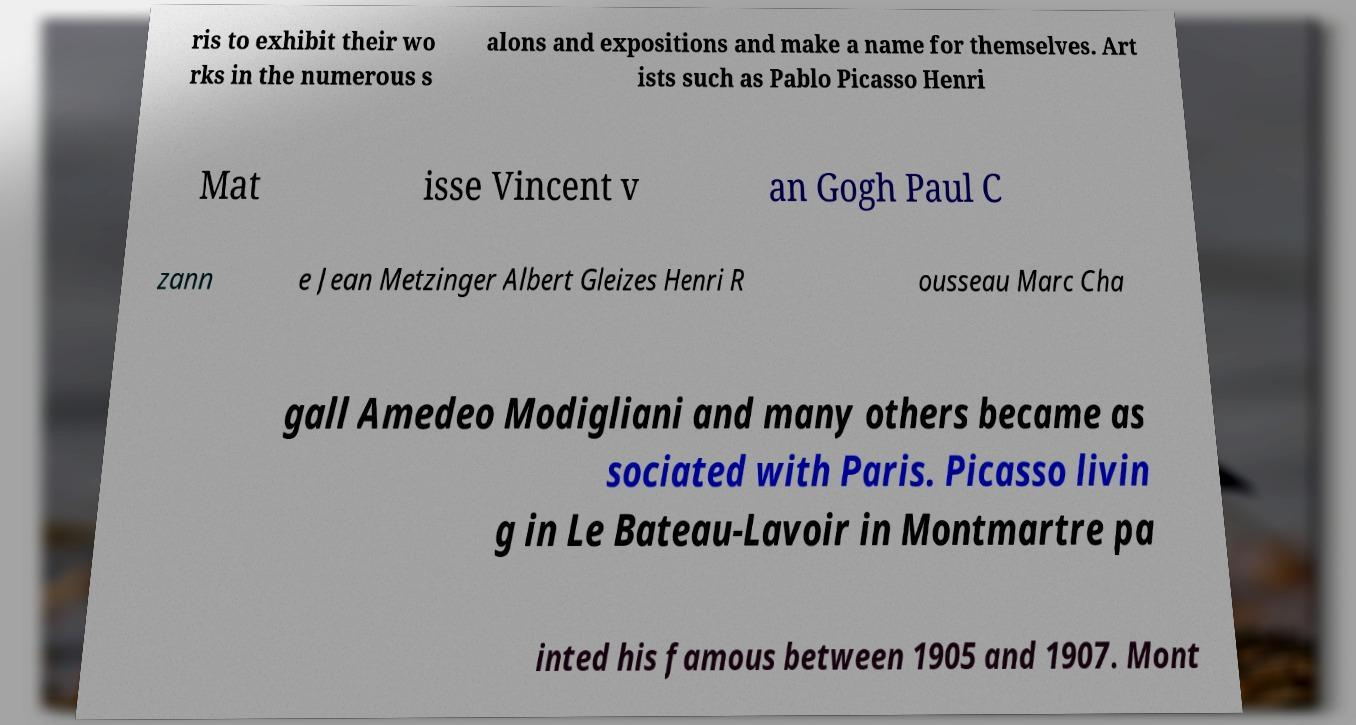I need the written content from this picture converted into text. Can you do that? ris to exhibit their wo rks in the numerous s alons and expositions and make a name for themselves. Art ists such as Pablo Picasso Henri Mat isse Vincent v an Gogh Paul C zann e Jean Metzinger Albert Gleizes Henri R ousseau Marc Cha gall Amedeo Modigliani and many others became as sociated with Paris. Picasso livin g in Le Bateau-Lavoir in Montmartre pa inted his famous between 1905 and 1907. Mont 